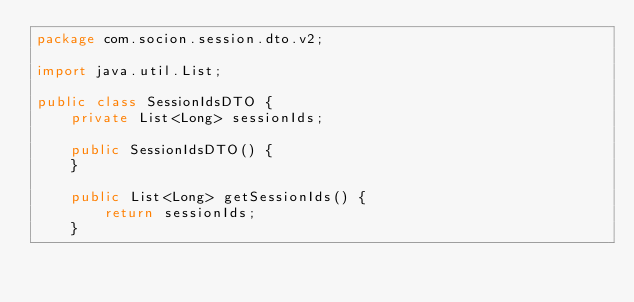Convert code to text. <code><loc_0><loc_0><loc_500><loc_500><_Java_>package com.socion.session.dto.v2;

import java.util.List;

public class SessionIdsDTO {
    private List<Long> sessionIds;

    public SessionIdsDTO() {
    }

    public List<Long> getSessionIds() {
        return sessionIds;
    }
</code> 